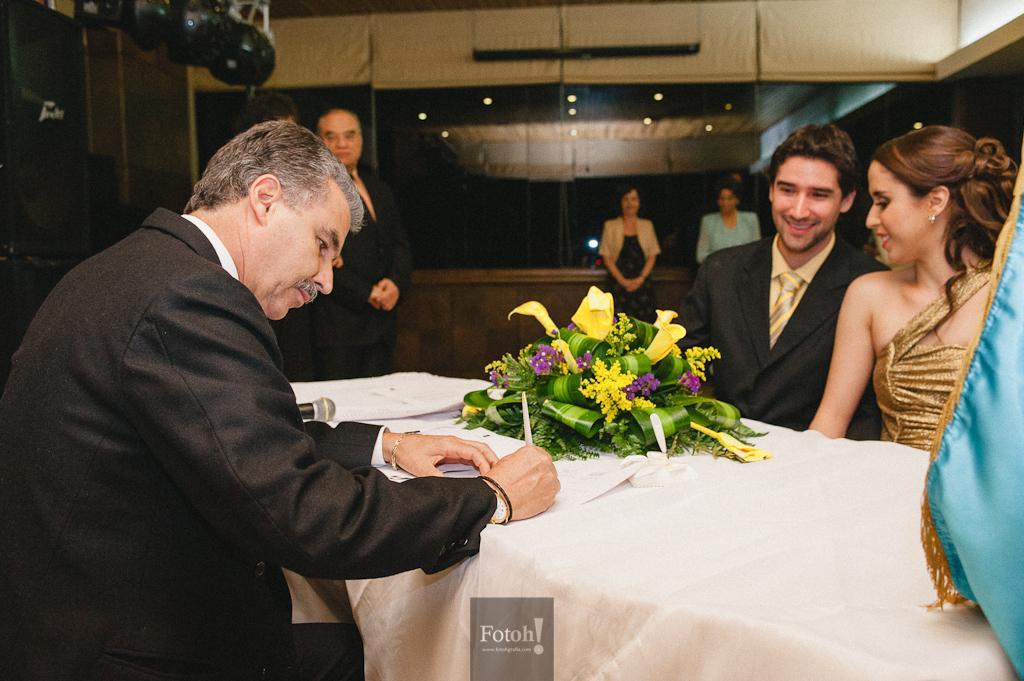How would you summarize this image in a sentence or two? In the center of the image there is a table and we can see a bouquet, papers and a mic placed on the table. On the left there is a man sitting and writing. In the background there are people standing. On the right we can see a lady and a man sitting on the chair. At the top there are lights. In the background there is a wall. 